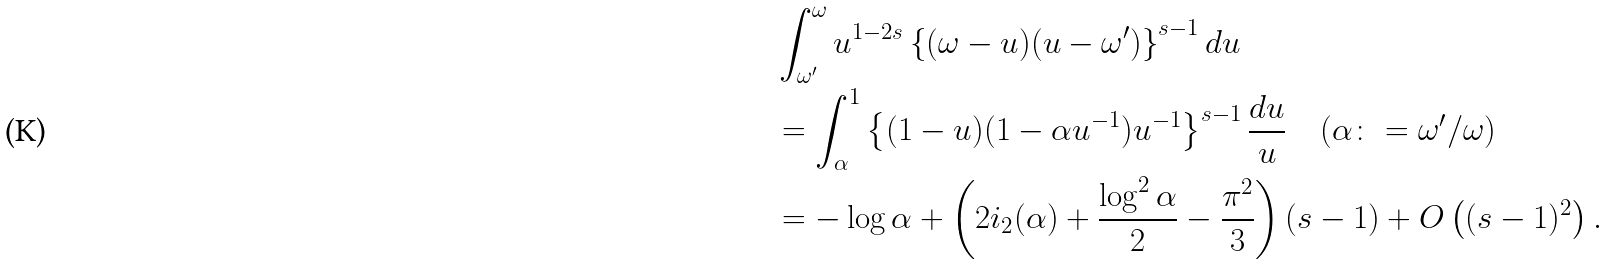<formula> <loc_0><loc_0><loc_500><loc_500>& \int _ { \omega ^ { \prime } } ^ { \omega } u ^ { 1 - 2 s } \left \{ ( \omega - u ) ( u - \omega ^ { \prime } ) \right \} ^ { s - 1 } d u \\ & = \int _ { \alpha } ^ { 1 } \left \{ ( 1 - u ) ( 1 - \alpha u ^ { - 1 } ) u ^ { - 1 } \right \} ^ { s - 1 } \frac { d u } { u } \quad ( \alpha \colon = \omega ^ { \prime } / \omega ) \\ & = - \log \alpha + \left ( 2 \L i _ { 2 } ( \alpha ) + \frac { \log ^ { 2 } \alpha } { 2 } - \frac { \pi ^ { 2 } } { 3 } \right ) ( s - 1 ) + O \left ( ( s - 1 ) ^ { 2 } \right ) .</formula> 